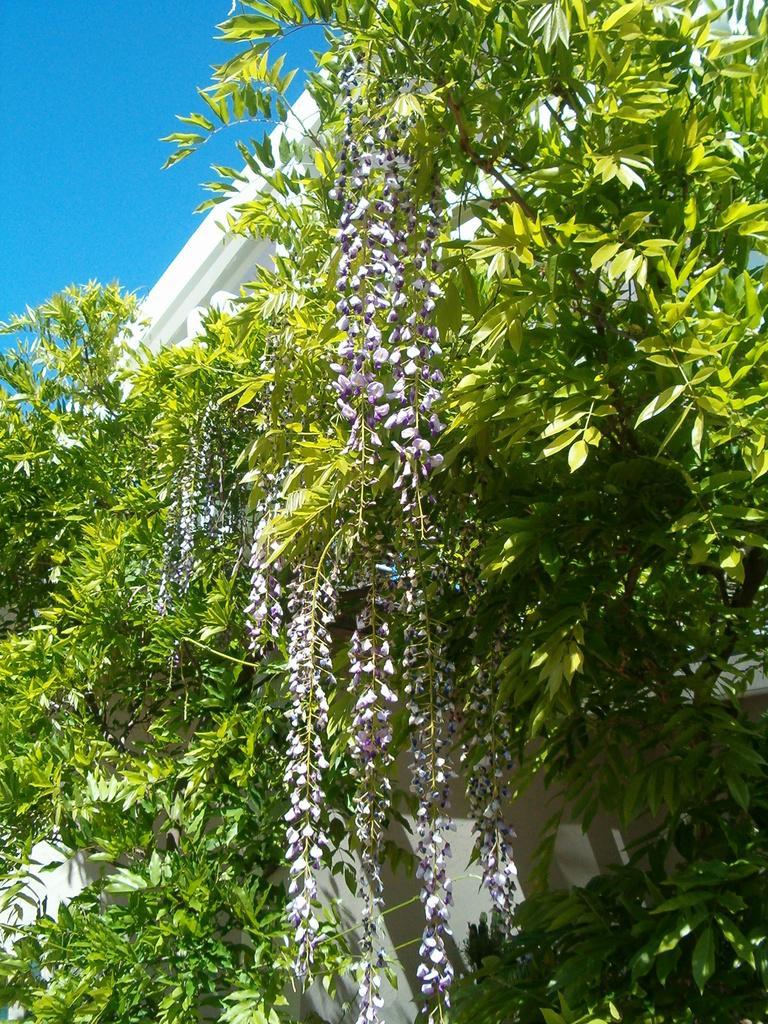Describe this image in one or two sentences. In this image in the front there are plants and there is a building which is white in colour. 